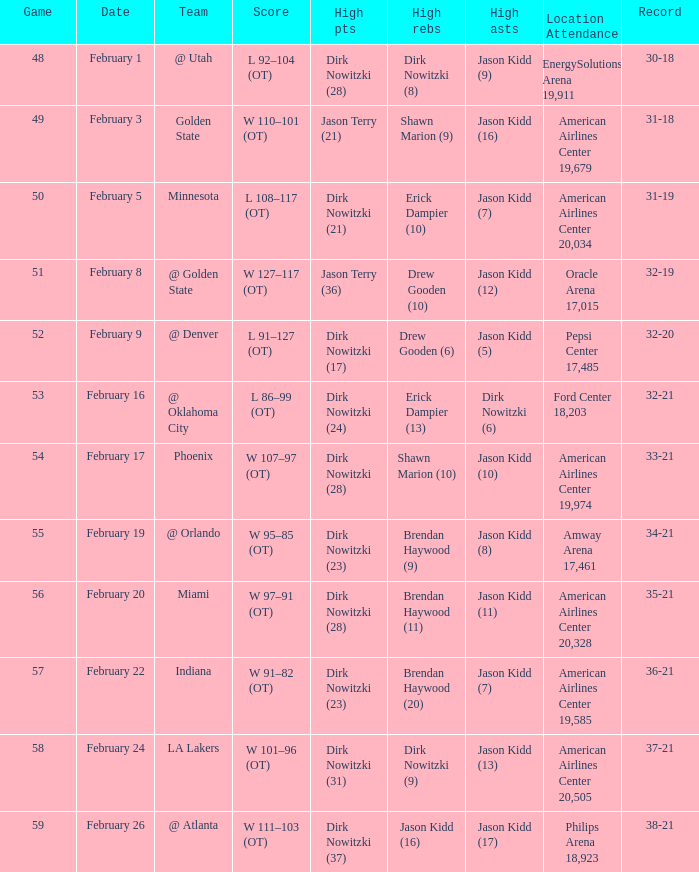Who had the most high assists with a record of 32-19? Jason Kidd (12). 